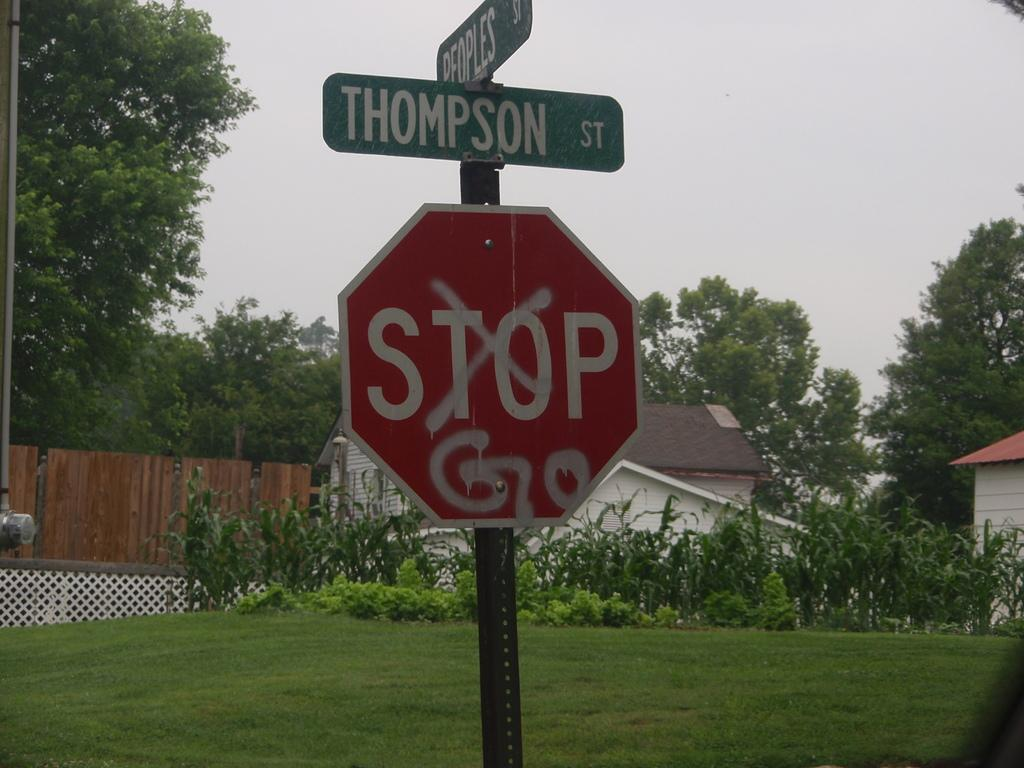Provide a one-sentence caption for the provided image. a red stop sign with the street signs on top. 